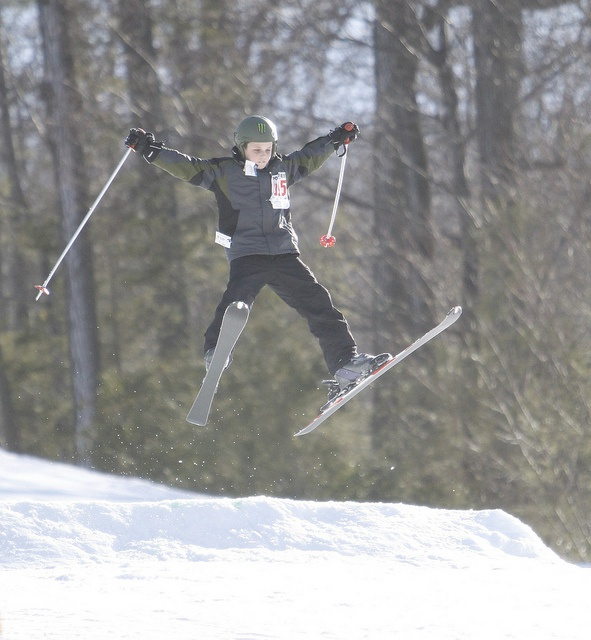Describe the objects in this image and their specific colors. I can see people in gray, darkgray, and lightgray tones and skis in gray, darkgray, and lightgray tones in this image. 